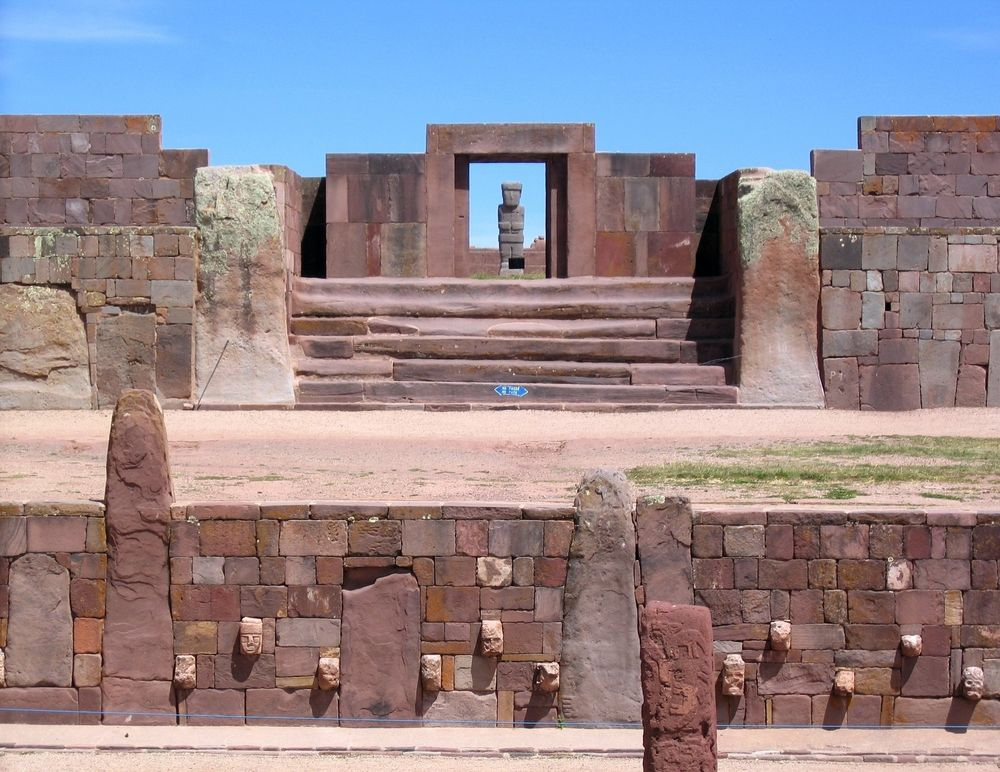Can you create a short story involving this site and the people who built it? In the heart of the Tiwanaku civilization, just as the first rays of the sun touched the ancient stones, young Kusi, an apprentice stoneworker, stood in awe before the grand staircase. He had heard tales from the elders about how this very site was conceived in dreams shared between their ancestors and the gods. On this particular morning, Kusi was to assist his master, Amaru, in restoring a section of the structure's intricate carvings. As they worked, Amaru shared the story of the site's creation, painting vivid images of the sacred ceremonies and the divine guidance received from Inti, the sun god. The rhythmic sound of chisel against stone mingled with the morning birds' songs, creating a symphony of devotion and craftsmanship. Suddenly, a procession approached, led by the high priestess, Mama Quilla. She carried a small, jeweled idol, intended for a newly carved niche. The ceremony that unfolded was breathtaking, as chants and offerings filled the air—a moment Kusi would treasure and recount to future generations. Thus, the legacy of the Tiwanaku was woven together through stone, story, and ceremony, with Kusi standing as both a guardian and a bridge between the past and the future. If this site were to be the setting of a fantasy novel, what kind of magical elements might it possess? The Tiwanaku site in a fantasy novel would be a place of unparalleled magic and wonder. The stones, meticulously carved with ancient runes, would hum with energy, acting as conduits for powerful elemental forces. The central staircase would be enchanted, allowing only those of pure intention to ascend and enter the ancient portal. The doorway itself would be a mystical gateway, capable of transporting individuals to different realms or times, keying to the rhythm of the celestial bodies. On solstices and equinoxes, the entire site would come alive with brilliant light displays, revealing hidden inscriptions and pathways. Ancient guardians, stone golems crafted by long-lost magics, would awaken to protect the sacred grounds from intruders. Meanwhile, the high priest or priestess would wield a staff imbued with the power to command the elements—earth, wind, fire, and water—channeling the energies of nature to preserve the balance of the world. The site would be surrounded by an ethereal mist, in which ethereal beings known as 'Wisps of Time,' manifestations of the ancient spirits of Tiwanaku, would guide worthy adventurers and impart forgotten wisdom. This mystical site would form the cornerstone of a world where magic is interwoven with history and the very essence of the universe. 